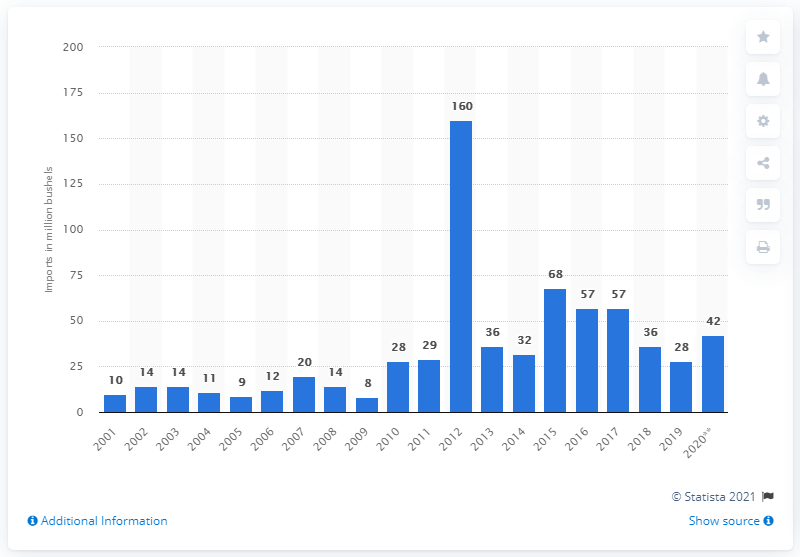Identify some key points in this picture. In 2016, the United States imported 57 bushels of corn. The previous year's imports of corn were 68. 